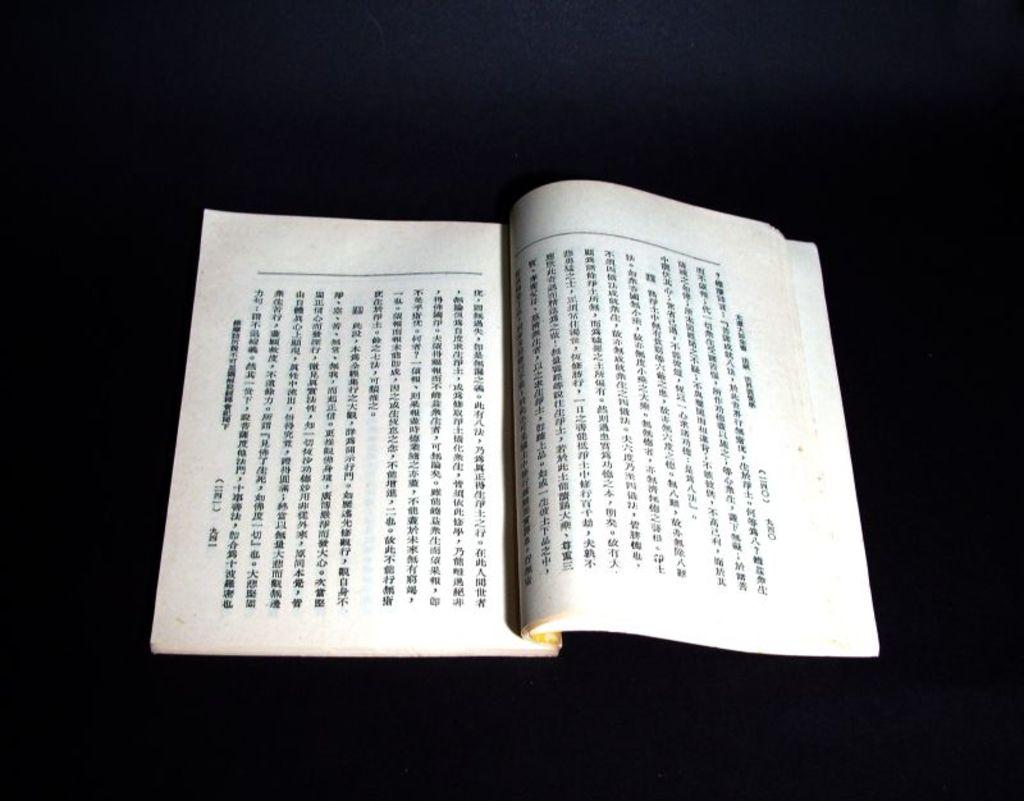What is the main subject of the image? There is a book in the center of the image. What can be found on the book? There is text on the book. What color is the background of the image? The background of the image is black. What type of hair can be seen on the book in the image? There is no hair present on the book in the image. Can you tell me how many chess pieces are visible on the book? There are no chess pieces visible on the book in the image. 